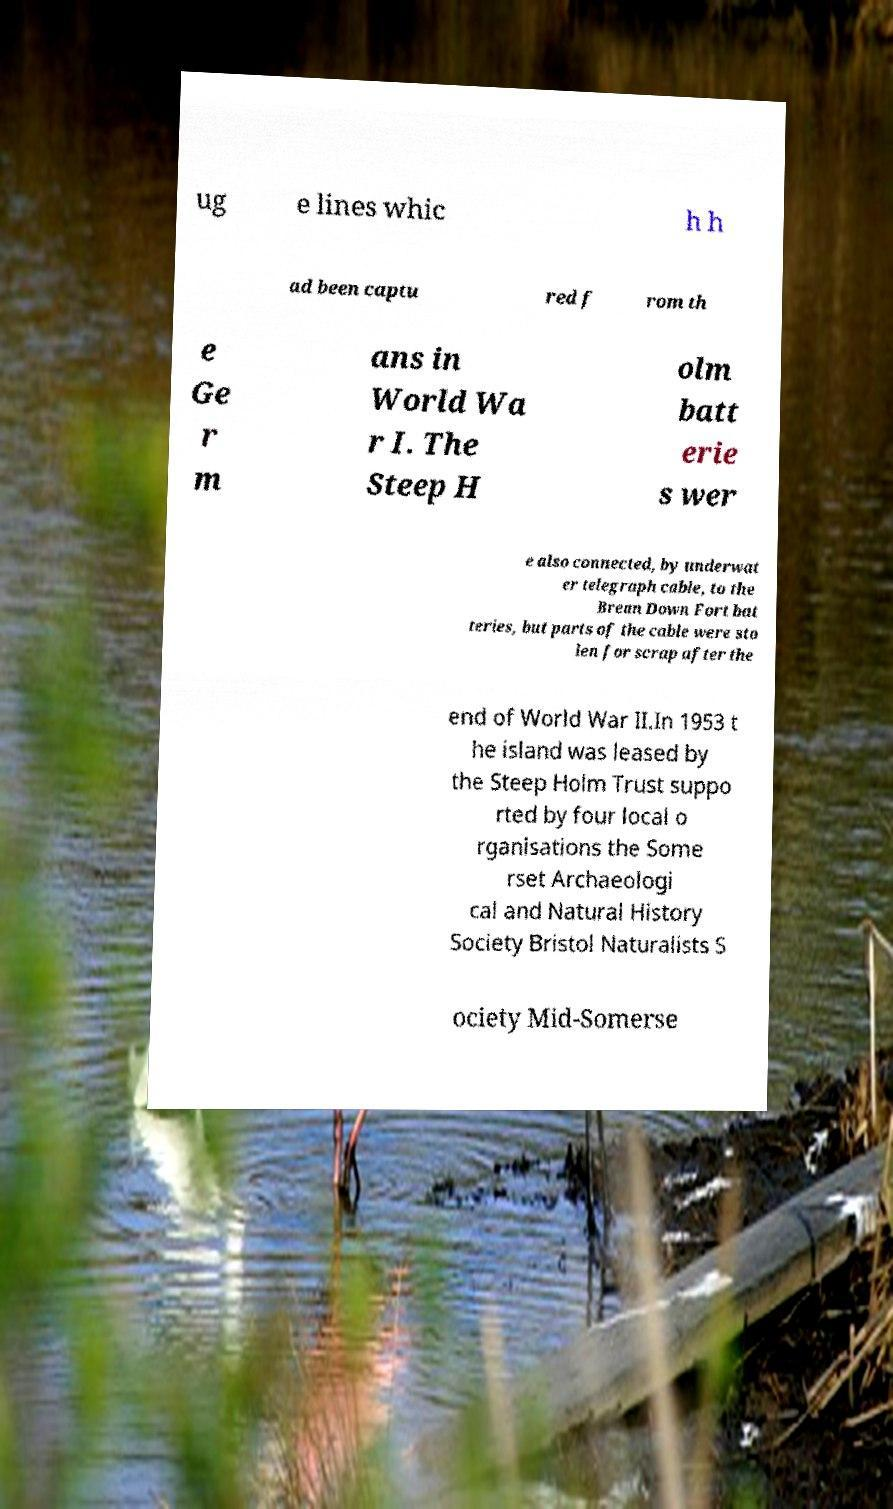There's text embedded in this image that I need extracted. Can you transcribe it verbatim? ug e lines whic h h ad been captu red f rom th e Ge r m ans in World Wa r I. The Steep H olm batt erie s wer e also connected, by underwat er telegraph cable, to the Brean Down Fort bat teries, but parts of the cable were sto len for scrap after the end of World War II.In 1953 t he island was leased by the Steep Holm Trust suppo rted by four local o rganisations the Some rset Archaeologi cal and Natural History Society Bristol Naturalists S ociety Mid-Somerse 